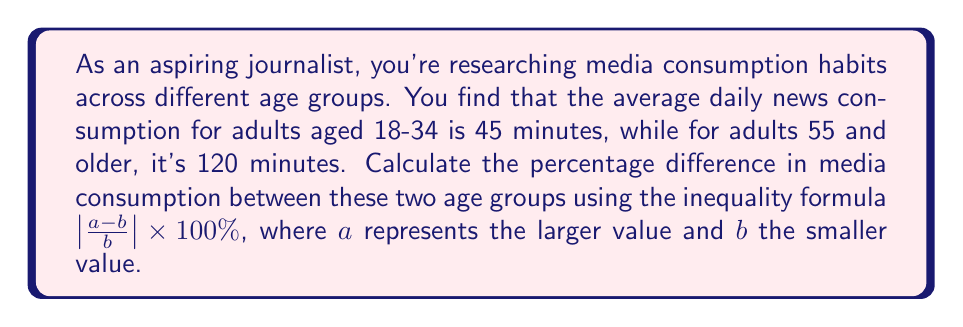Can you answer this question? To solve this problem, we'll follow these steps:

1. Identify the larger and smaller values:
   $a = 120$ minutes (adults 55 and older)
   $b = 45$ minutes (adults 18-34)

2. Apply the percentage difference formula:
   $\text{Percentage Difference} = |\frac{a-b}{b}| \times 100\%$

3. Substitute the values into the formula:
   $|\frac{120-45}{45}| \times 100\%$

4. Simplify the numerator:
   $|\frac{75}{45}| \times 100\%$

5. Divide within the absolute value brackets:
   $|1.6666...| \times 100\%$

6. The absolute value of a positive number is the number itself, so we can remove the brackets:
   $1.6666... \times 100\%$

7. Multiply by 100% to get the final percentage:
   $166.67\%$ (rounded to two decimal places)
Answer: 166.67% 